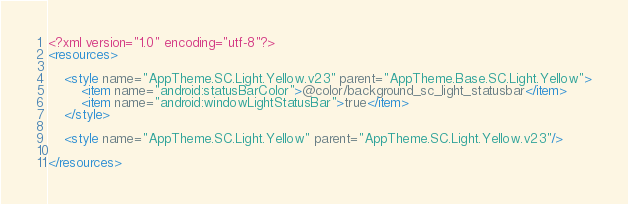Convert code to text. <code><loc_0><loc_0><loc_500><loc_500><_XML_><?xml version="1.0" encoding="utf-8"?>
<resources>

    <style name="AppTheme.SC.Light.Yellow.v23" parent="AppTheme.Base.SC.Light.Yellow">
        <item name="android:statusBarColor">@color/background_sc_light_statusbar</item>
        <item name="android:windowLightStatusBar">true</item>
    </style>

    <style name="AppTheme.SC.Light.Yellow" parent="AppTheme.SC.Light.Yellow.v23"/>

</resources>
</code> 